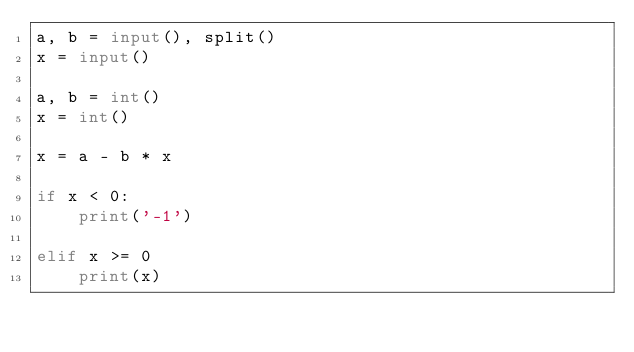Convert code to text. <code><loc_0><loc_0><loc_500><loc_500><_Python_>a, b = input(), split()
x = input()

a, b = int()
x = int()

x = a - b * x

if x < 0:
    print('-1')
    
elif x >= 0
    print(x)
</code> 